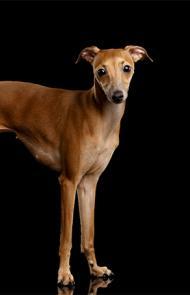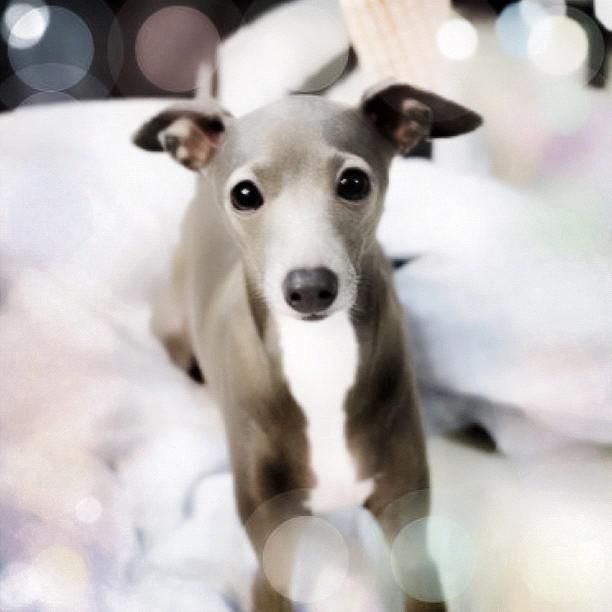The first image is the image on the left, the second image is the image on the right. Given the left and right images, does the statement "At least one of the dogs is standing on all fours." hold true? Answer yes or no. Yes. The first image is the image on the left, the second image is the image on the right. Considering the images on both sides, is "One image shows one non-spotted dog in a standing pose." valid? Answer yes or no. Yes. 